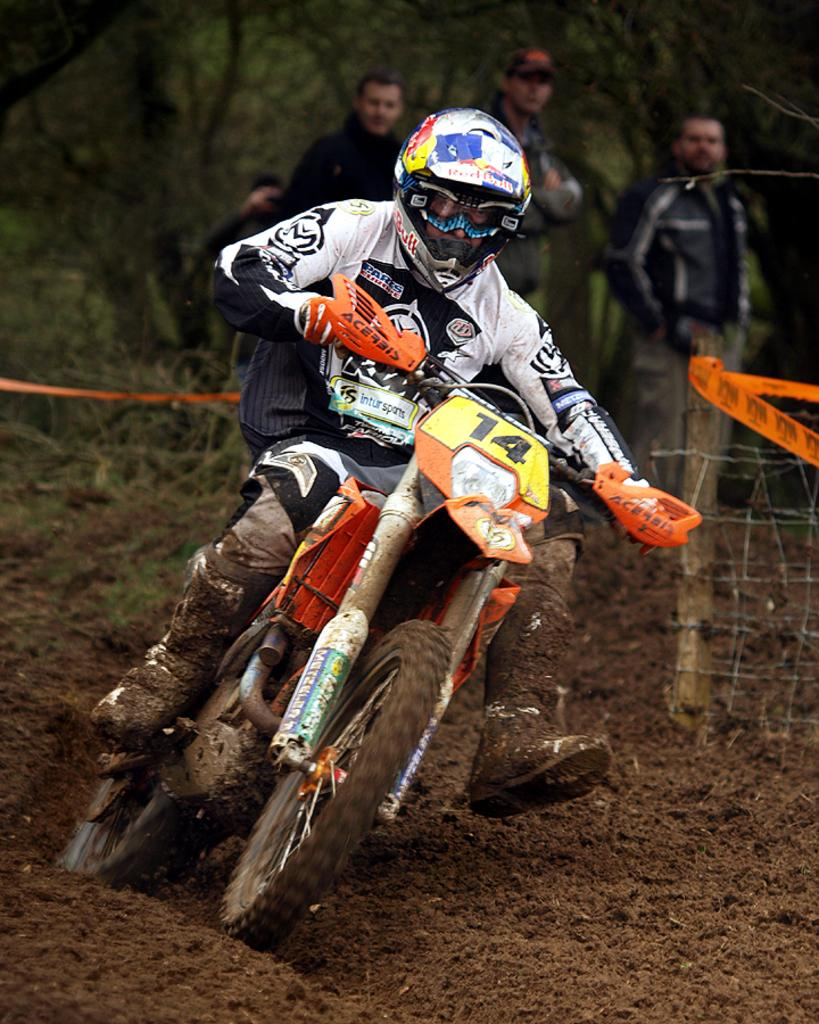What is the main subject of the image? The main subject of the image is a person on a bike. What is the person wearing in the image? The person is wearing a jacket and a helmet. What type of surface can be seen in the image? The surface in the image has sand. Can you see any ladybugs crawling on the person's helmet in the image? There are no ladybugs visible on the person's helmet in the image. Is the person on the bike taking a bath in the image? The image does not depict the person on the bike taking a bath. Are there any police officers present in the image? There is no indication of any police officers in the image. 